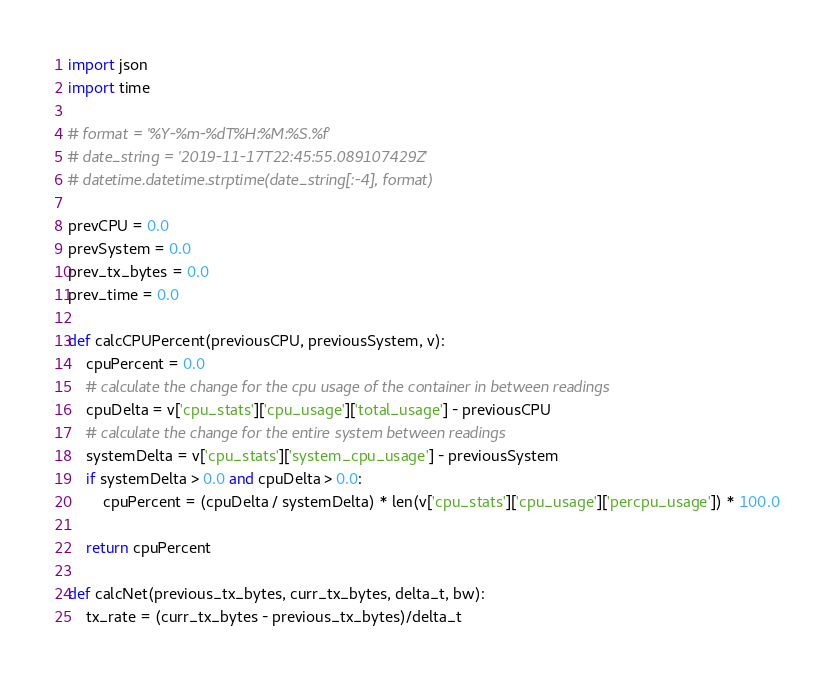Convert code to text. <code><loc_0><loc_0><loc_500><loc_500><_Python_>import json
import time

# format = '%Y-%m-%dT%H:%M:%S.%f'
# date_string = '2019-11-17T22:45:55.089107429Z'
# datetime.datetime.strptime(date_string[:-4], format)

prevCPU = 0.0
prevSystem = 0.0
prev_tx_bytes = 0.0
prev_time = 0.0

def calcCPUPercent(previousCPU, previousSystem, v):
    cpuPercent = 0.0
    # calculate the change for the cpu usage of the container in between readings
    cpuDelta = v['cpu_stats']['cpu_usage']['total_usage'] - previousCPU
    # calculate the change for the entire system between readings
    systemDelta = v['cpu_stats']['system_cpu_usage'] - previousSystem
    if systemDelta > 0.0 and cpuDelta > 0.0:
        cpuPercent = (cpuDelta / systemDelta) * len(v['cpu_stats']['cpu_usage']['percpu_usage']) * 100.0

    return cpuPercent

def calcNet(previous_tx_bytes, curr_tx_bytes, delta_t, bw):
	tx_rate = (curr_tx_bytes - previous_tx_bytes)/delta_t</code> 